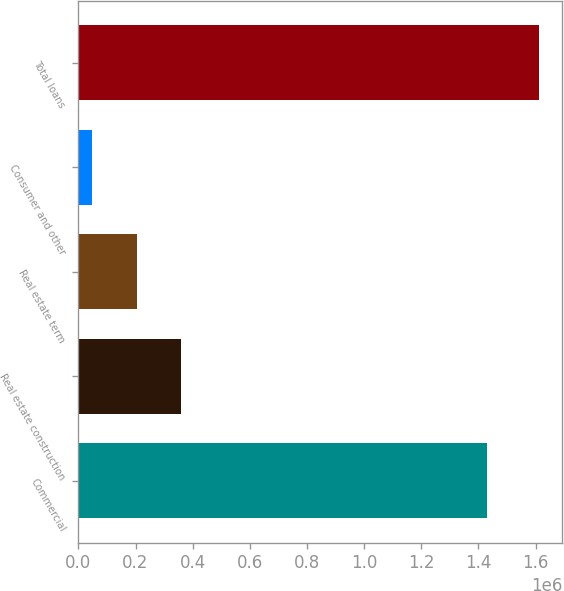Convert chart to OTSL. <chart><loc_0><loc_0><loc_500><loc_500><bar_chart><fcel>Commercial<fcel>Real estate construction<fcel>Real estate term<fcel>Consumer and other<fcel>Total loans<nl><fcel>1.42998e+06<fcel>360046<fcel>203561<fcel>47077<fcel>1.61192e+06<nl></chart> 